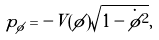<formula> <loc_0><loc_0><loc_500><loc_500>p _ { \phi } = - V ( \phi ) \sqrt { 1 - \dot { \phi } ^ { 2 } } ,</formula> 